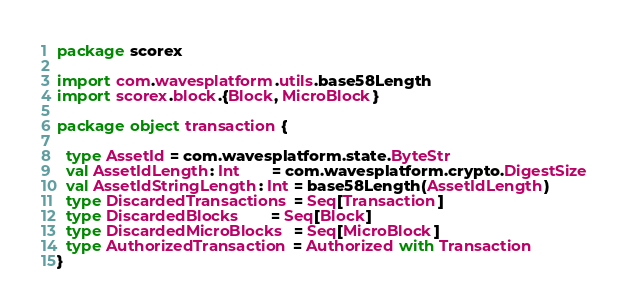<code> <loc_0><loc_0><loc_500><loc_500><_Scala_>package scorex

import com.wavesplatform.utils.base58Length
import scorex.block.{Block, MicroBlock}

package object transaction {

  type AssetId = com.wavesplatform.state.ByteStr
  val AssetIdLength: Int       = com.wavesplatform.crypto.DigestSize
  val AssetIdStringLength: Int = base58Length(AssetIdLength)
  type DiscardedTransactions = Seq[Transaction]
  type DiscardedBlocks       = Seq[Block]
  type DiscardedMicroBlocks  = Seq[MicroBlock]
  type AuthorizedTransaction = Authorized with Transaction
}
</code> 